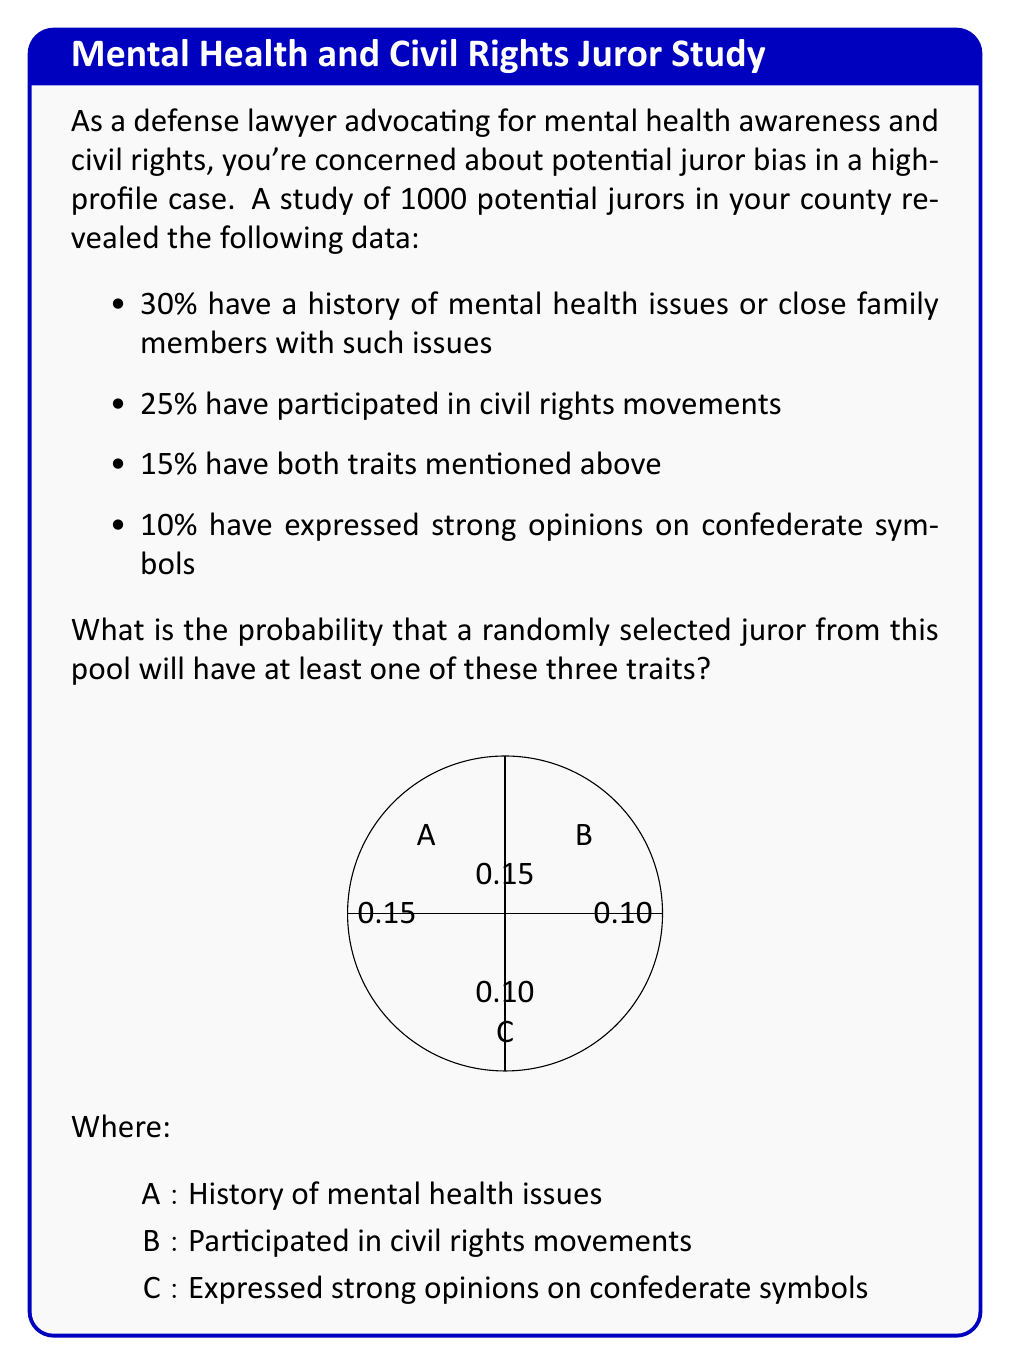Provide a solution to this math problem. Let's approach this step-by-step using the inclusion-exclusion principle:

1) Let's define our events:
   A: History of mental health issues
   B: Participated in civil rights movements
   C: Expressed strong opinions on confederate symbols

2) We're given:
   P(A) = 0.30
   P(B) = 0.25
   P(A ∩ B) = 0.15
   P(C) = 0.10

3) We need to find P(A ∪ B ∪ C). The inclusion-exclusion principle states:

   P(A ∪ B ∪ C) = P(A) + P(B) + P(C) - P(A ∩ B) - P(A ∩ C) - P(B ∩ C) + P(A ∩ B ∩ C)

4) We're not given P(A ∩ C), P(B ∩ C), or P(A ∩ B ∩ C). However, we can assume these intersections are 0 to find the minimum probability:

   P(A ∪ B ∪ C) ≥ P(A) + P(B) + P(C) - P(A ∩ B)

5) Substituting the values:

   P(A ∪ B ∪ C) ≥ 0.30 + 0.25 + 0.10 - 0.15

6) Calculating:

   P(A ∪ B ∪ C) ≥ 0.50 or 50%

Therefore, the probability that a randomly selected juror will have at least one of these three traits is at least 50%.
Answer: At least 50% 